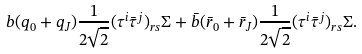<formula> <loc_0><loc_0><loc_500><loc_500>b ( q _ { 0 } + q _ { J } ) \frac { 1 } { 2 \sqrt { 2 } } ( \tau ^ { i } \bar { \tau } ^ { j } ) _ { r s } \Sigma + \bar { b } ( \bar { r } _ { 0 } + \bar { r } _ { J } ) \frac { 1 } { 2 \sqrt { 2 } } ( \tau ^ { i } \bar { \tau } ^ { j } ) _ { r s } \Sigma .</formula> 